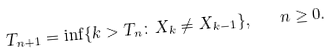<formula> <loc_0><loc_0><loc_500><loc_500>T _ { n + 1 } = \inf \{ k > T _ { n } \colon X _ { k } \ne X _ { k - 1 } \} , \quad n \geq 0 .</formula> 